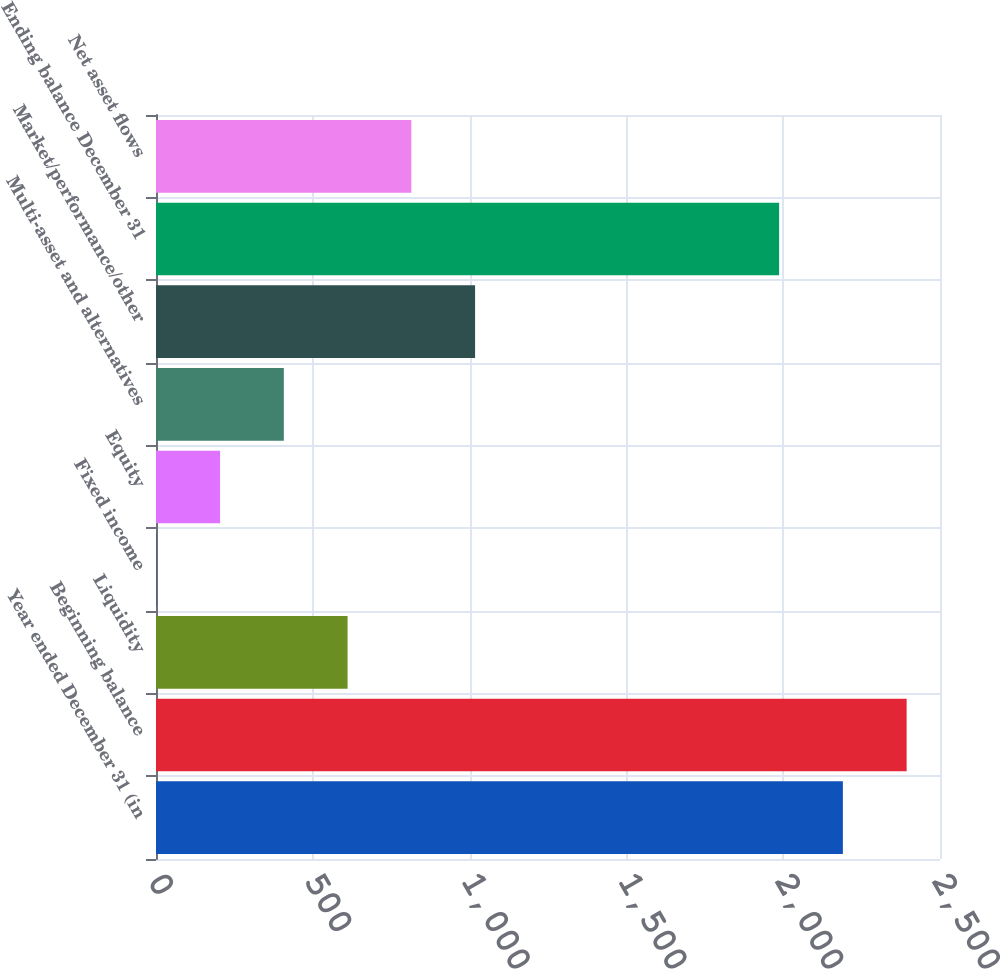<chart> <loc_0><loc_0><loc_500><loc_500><bar_chart><fcel>Year ended December 31 (in<fcel>Beginning balance<fcel>Liquidity<fcel>Fixed income<fcel>Equity<fcel>Multi-asset and alternatives<fcel>Market/performance/other<fcel>Ending balance December 31<fcel>Net asset flows<nl><fcel>2190.3<fcel>2393.6<fcel>610.9<fcel>1<fcel>204.3<fcel>407.6<fcel>1017.5<fcel>1987<fcel>814.2<nl></chart> 